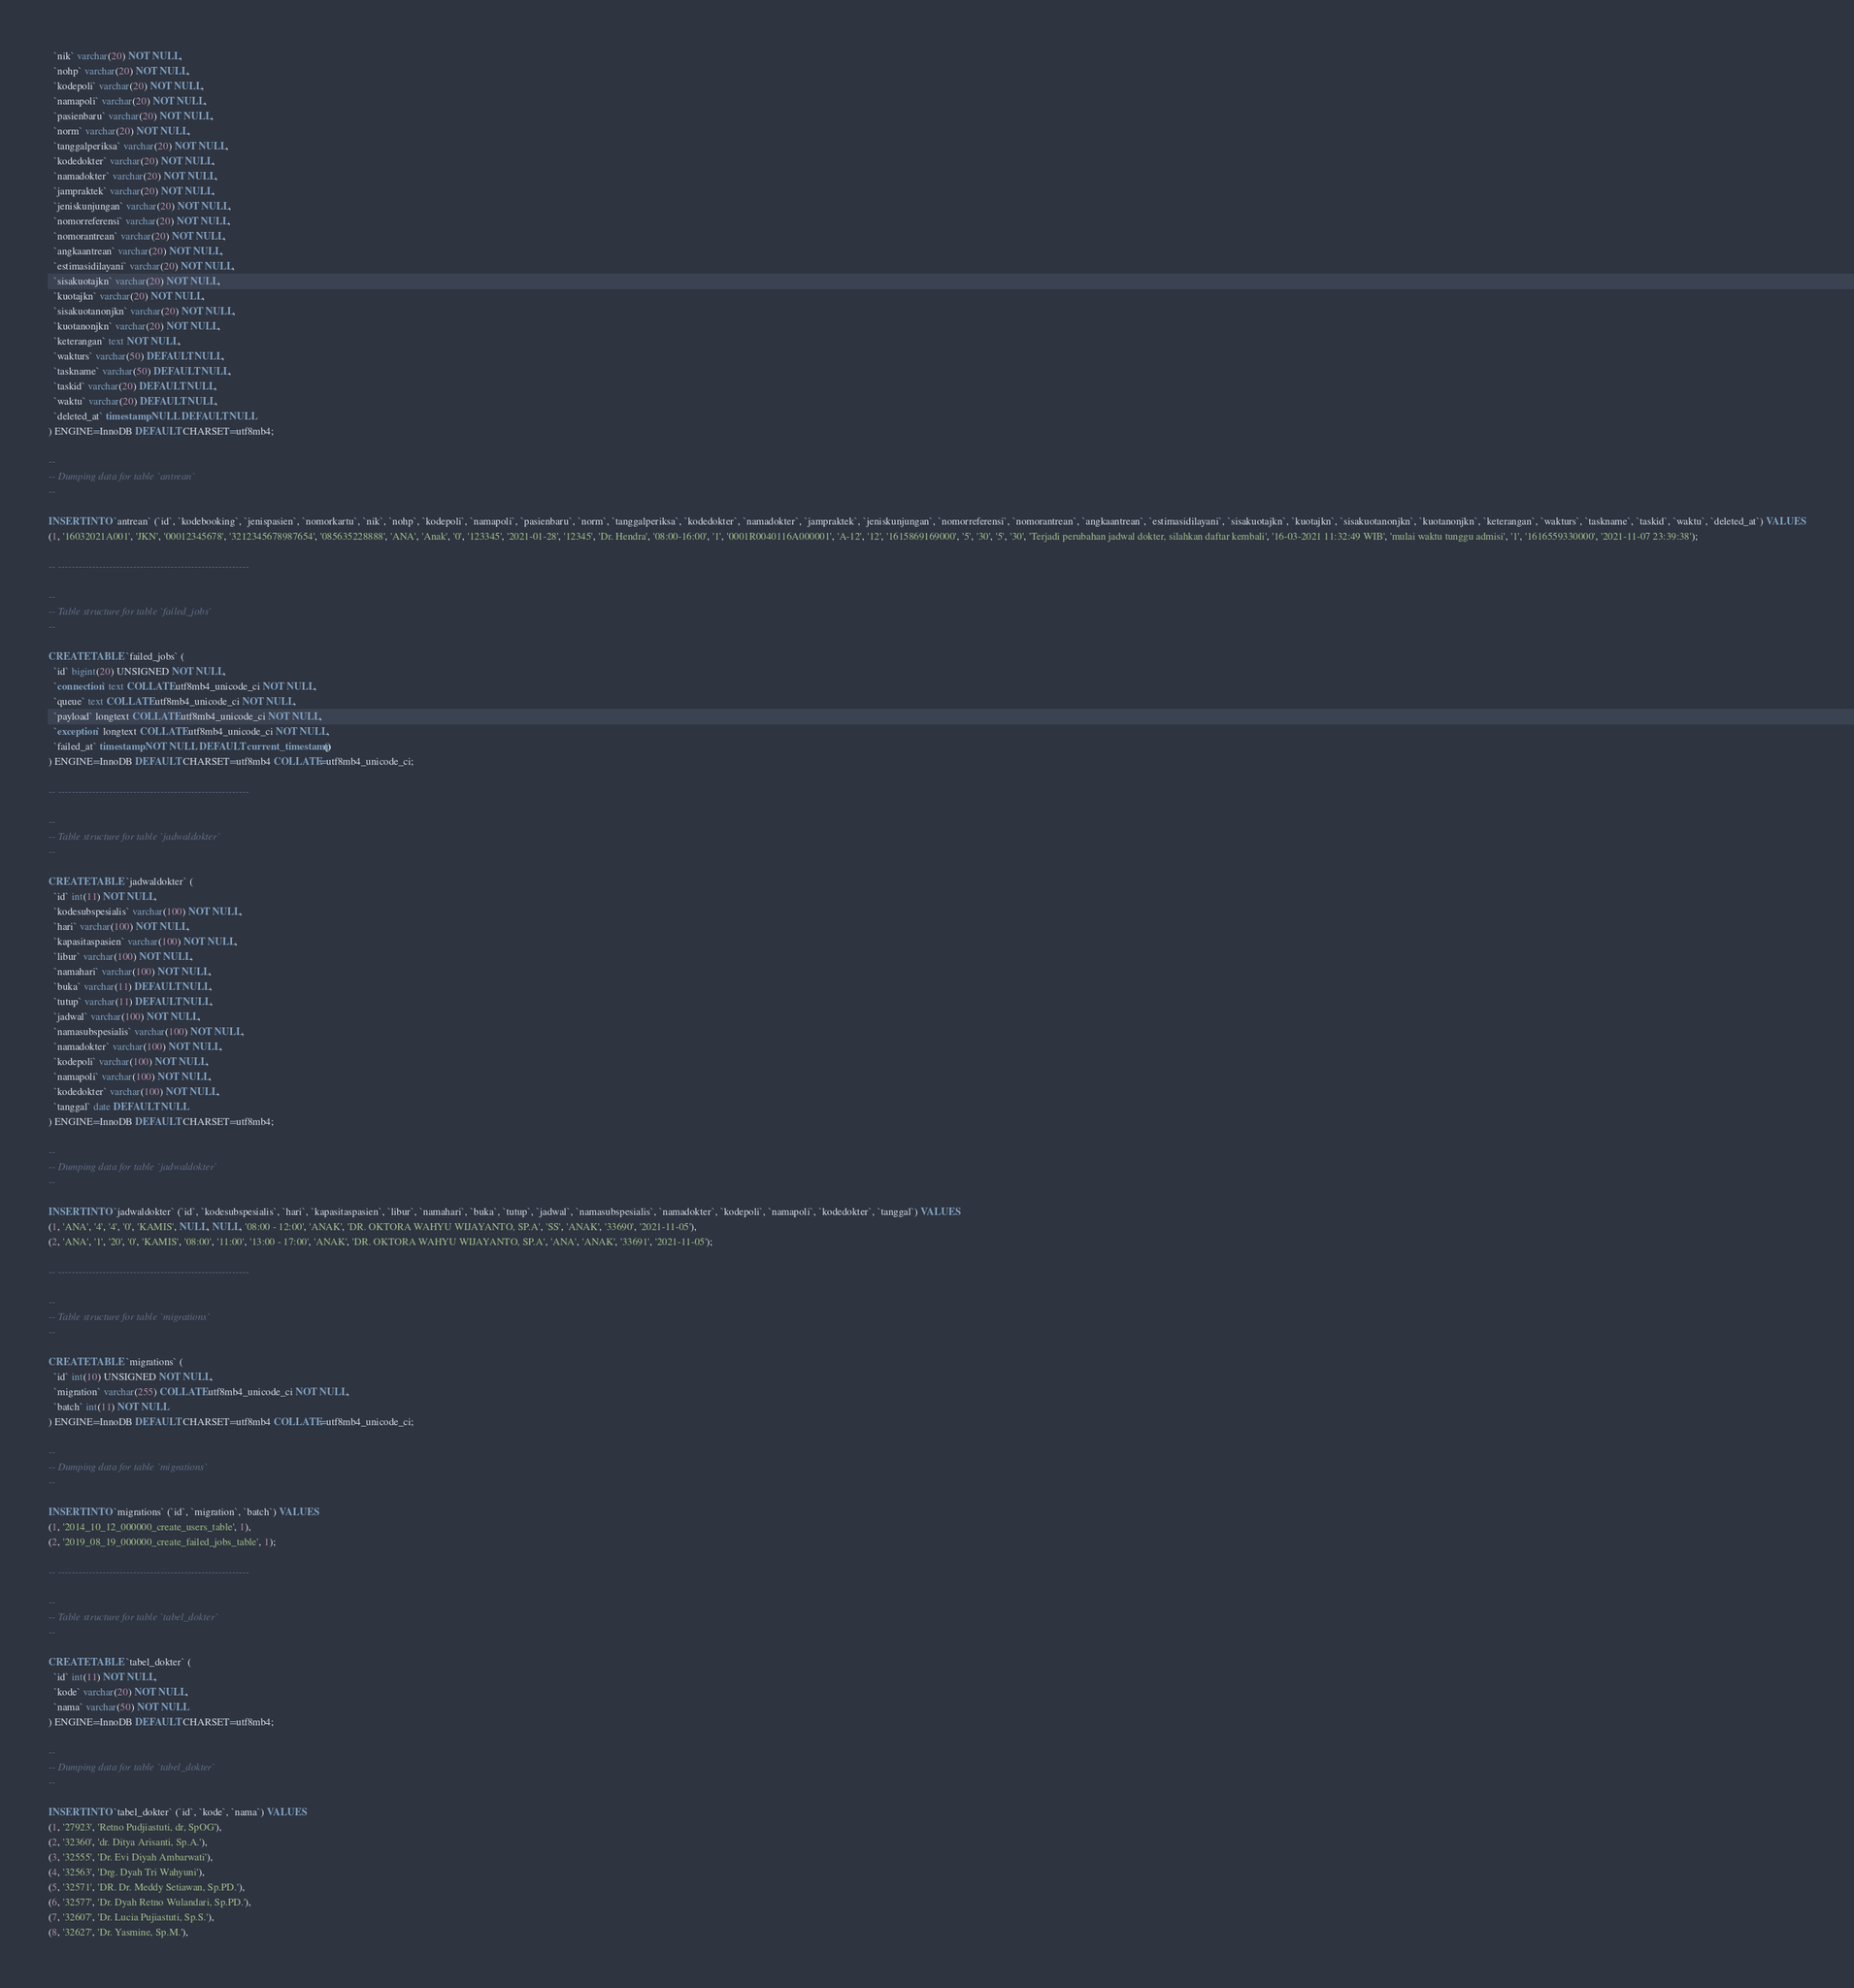Convert code to text. <code><loc_0><loc_0><loc_500><loc_500><_SQL_>  `nik` varchar(20) NOT NULL,
  `nohp` varchar(20) NOT NULL,
  `kodepoli` varchar(20) NOT NULL,
  `namapoli` varchar(20) NOT NULL,
  `pasienbaru` varchar(20) NOT NULL,
  `norm` varchar(20) NOT NULL,
  `tanggalperiksa` varchar(20) NOT NULL,
  `kodedokter` varchar(20) NOT NULL,
  `namadokter` varchar(20) NOT NULL,
  `jampraktek` varchar(20) NOT NULL,
  `jeniskunjungan` varchar(20) NOT NULL,
  `nomorreferensi` varchar(20) NOT NULL,
  `nomorantrean` varchar(20) NOT NULL,
  `angkaantrean` varchar(20) NOT NULL,
  `estimasidilayani` varchar(20) NOT NULL,
  `sisakuotajkn` varchar(20) NOT NULL,
  `kuotajkn` varchar(20) NOT NULL,
  `sisakuotanonjkn` varchar(20) NOT NULL,
  `kuotanonjkn` varchar(20) NOT NULL,
  `keterangan` text NOT NULL,
  `wakturs` varchar(50) DEFAULT NULL,
  `taskname` varchar(50) DEFAULT NULL,
  `taskid` varchar(20) DEFAULT NULL,
  `waktu` varchar(20) DEFAULT NULL,
  `deleted_at` timestamp NULL DEFAULT NULL
) ENGINE=InnoDB DEFAULT CHARSET=utf8mb4;

--
-- Dumping data for table `antrean`
--

INSERT INTO `antrean` (`id`, `kodebooking`, `jenispasien`, `nomorkartu`, `nik`, `nohp`, `kodepoli`, `namapoli`, `pasienbaru`, `norm`, `tanggalperiksa`, `kodedokter`, `namadokter`, `jampraktek`, `jeniskunjungan`, `nomorreferensi`, `nomorantrean`, `angkaantrean`, `estimasidilayani`, `sisakuotajkn`, `kuotajkn`, `sisakuotanonjkn`, `kuotanonjkn`, `keterangan`, `wakturs`, `taskname`, `taskid`, `waktu`, `deleted_at`) VALUES
(1, '16032021A001', 'JKN', '00012345678', '3212345678987654', '085635228888', 'ANA', 'Anak', '0', '123345', '2021-01-28', '12345', 'Dr. Hendra', '08:00-16:00', '1', '0001R0040116A000001', 'A-12', '12', '1615869169000', '5', '30', '5', '30', 'Terjadi perubahan jadwal dokter, silahkan daftar kembali', '16-03-2021 11:32:49 WIB', 'mulai waktu tunggu admisi', '1', '1616559330000', '2021-11-07 23:39:38');

-- --------------------------------------------------------

--
-- Table structure for table `failed_jobs`
--

CREATE TABLE `failed_jobs` (
  `id` bigint(20) UNSIGNED NOT NULL,
  `connection` text COLLATE utf8mb4_unicode_ci NOT NULL,
  `queue` text COLLATE utf8mb4_unicode_ci NOT NULL,
  `payload` longtext COLLATE utf8mb4_unicode_ci NOT NULL,
  `exception` longtext COLLATE utf8mb4_unicode_ci NOT NULL,
  `failed_at` timestamp NOT NULL DEFAULT current_timestamp()
) ENGINE=InnoDB DEFAULT CHARSET=utf8mb4 COLLATE=utf8mb4_unicode_ci;

-- --------------------------------------------------------

--
-- Table structure for table `jadwaldokter`
--

CREATE TABLE `jadwaldokter` (
  `id` int(11) NOT NULL,
  `kodesubspesialis` varchar(100) NOT NULL,
  `hari` varchar(100) NOT NULL,
  `kapasitaspasien` varchar(100) NOT NULL,
  `libur` varchar(100) NOT NULL,
  `namahari` varchar(100) NOT NULL,
  `buka` varchar(11) DEFAULT NULL,
  `tutup` varchar(11) DEFAULT NULL,
  `jadwal` varchar(100) NOT NULL,
  `namasubspesialis` varchar(100) NOT NULL,
  `namadokter` varchar(100) NOT NULL,
  `kodepoli` varchar(100) NOT NULL,
  `namapoli` varchar(100) NOT NULL,
  `kodedokter` varchar(100) NOT NULL,
  `tanggal` date DEFAULT NULL
) ENGINE=InnoDB DEFAULT CHARSET=utf8mb4;

--
-- Dumping data for table `jadwaldokter`
--

INSERT INTO `jadwaldokter` (`id`, `kodesubspesialis`, `hari`, `kapasitaspasien`, `libur`, `namahari`, `buka`, `tutup`, `jadwal`, `namasubspesialis`, `namadokter`, `kodepoli`, `namapoli`, `kodedokter`, `tanggal`) VALUES
(1, 'ANA', '4', '4', '0', 'KAMIS', NULL, NULL, '08:00 - 12:00', 'ANAK', 'DR. OKTORA WAHYU WIJAYANTO, SP.A', 'SS', 'ANAK', '33690', '2021-11-05'),
(2, 'ANA', '1', '20', '0', 'KAMIS', '08:00', '11:00', '13:00 - 17:00', 'ANAK', 'DR. OKTORA WAHYU WIJAYANTO, SP.A', 'ANA', 'ANAK', '33691', '2021-11-05');

-- --------------------------------------------------------

--
-- Table structure for table `migrations`
--

CREATE TABLE `migrations` (
  `id` int(10) UNSIGNED NOT NULL,
  `migration` varchar(255) COLLATE utf8mb4_unicode_ci NOT NULL,
  `batch` int(11) NOT NULL
) ENGINE=InnoDB DEFAULT CHARSET=utf8mb4 COLLATE=utf8mb4_unicode_ci;

--
-- Dumping data for table `migrations`
--

INSERT INTO `migrations` (`id`, `migration`, `batch`) VALUES
(1, '2014_10_12_000000_create_users_table', 1),
(2, '2019_08_19_000000_create_failed_jobs_table', 1);

-- --------------------------------------------------------

--
-- Table structure for table `tabel_dokter`
--

CREATE TABLE `tabel_dokter` (
  `id` int(11) NOT NULL,
  `kode` varchar(20) NOT NULL,
  `nama` varchar(50) NOT NULL
) ENGINE=InnoDB DEFAULT CHARSET=utf8mb4;

--
-- Dumping data for table `tabel_dokter`
--

INSERT INTO `tabel_dokter` (`id`, `kode`, `nama`) VALUES
(1, '27923', 'Retno Pudjiastuti, dr, SpOG'),
(2, '32360', 'dr. Ditya Arisanti, Sp.A.'),
(3, '32555', 'Dr. Evi Diyah Ambarwati'),
(4, '32563', 'Drg. Dyah Tri Wahyuni'),
(5, '32571', 'DR. Dr. Meddy Setiawan, Sp.PD.'),
(6, '32577', 'Dr. Dyah Retno Wulandari, Sp.PD.'),
(7, '32607', 'Dr. Lucia Pujiastuti, Sp.S.'),
(8, '32627', 'Dr. Yasmine, Sp.M.'),</code> 